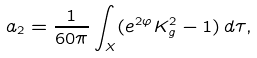Convert formula to latex. <formula><loc_0><loc_0><loc_500><loc_500>a _ { 2 } = \frac { 1 } { 6 0 \pi } \int _ { X } ( e ^ { 2 \varphi } K _ { g } ^ { 2 } - 1 ) \, d \tau ,</formula> 